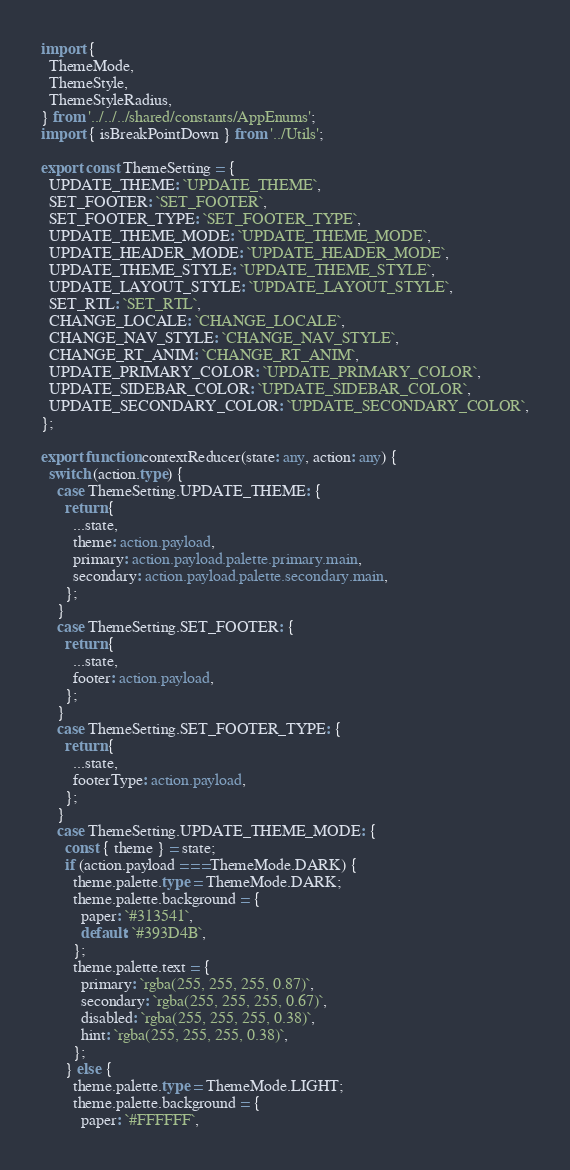<code> <loc_0><loc_0><loc_500><loc_500><_TypeScript_>import {
  ThemeMode,
  ThemeStyle,
  ThemeStyleRadius,
} from '../../../shared/constants/AppEnums';
import { isBreakPointDown } from '../Utils';

export const ThemeSetting = {
  UPDATE_THEME: `UPDATE_THEME`,
  SET_FOOTER: `SET_FOOTER`,
  SET_FOOTER_TYPE: `SET_FOOTER_TYPE`,
  UPDATE_THEME_MODE: `UPDATE_THEME_MODE`,
  UPDATE_HEADER_MODE: `UPDATE_HEADER_MODE`,
  UPDATE_THEME_STYLE: `UPDATE_THEME_STYLE`,
  UPDATE_LAYOUT_STYLE: `UPDATE_LAYOUT_STYLE`,
  SET_RTL: `SET_RTL`,
  CHANGE_LOCALE: `CHANGE_LOCALE`,
  CHANGE_NAV_STYLE: `CHANGE_NAV_STYLE`,
  CHANGE_RT_ANIM: `CHANGE_RT_ANIM`,
  UPDATE_PRIMARY_COLOR: `UPDATE_PRIMARY_COLOR`,
  UPDATE_SIDEBAR_COLOR: `UPDATE_SIDEBAR_COLOR`,
  UPDATE_SECONDARY_COLOR: `UPDATE_SECONDARY_COLOR`,
};

export function contextReducer(state: any, action: any) {
  switch (action.type) {
    case ThemeSetting.UPDATE_THEME: {
      return {
        ...state,
        theme: action.payload,
        primary: action.payload.palette.primary.main,
        secondary: action.payload.palette.secondary.main,
      };
    }
    case ThemeSetting.SET_FOOTER: {
      return {
        ...state,
        footer: action.payload,
      };
    }
    case ThemeSetting.SET_FOOTER_TYPE: {
      return {
        ...state,
        footerType: action.payload,
      };
    }
    case ThemeSetting.UPDATE_THEME_MODE: {
      const { theme } = state;
      if (action.payload === ThemeMode.DARK) {
        theme.palette.type = ThemeMode.DARK;
        theme.palette.background = {
          paper: `#313541`,
          default: `#393D4B`,
        };
        theme.palette.text = {
          primary: `rgba(255, 255, 255, 0.87)`,
          secondary: `rgba(255, 255, 255, 0.67)`,
          disabled: `rgba(255, 255, 255, 0.38)`,
          hint: `rgba(255, 255, 255, 0.38)`,
        };
      } else {
        theme.palette.type = ThemeMode.LIGHT;
        theme.palette.background = {
          paper: `#FFFFFF`,</code> 